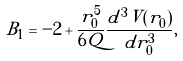Convert formula to latex. <formula><loc_0><loc_0><loc_500><loc_500>B _ { 1 } = - 2 + \frac { r _ { 0 } ^ { 5 } } { 6 Q } \frac { d ^ { 3 } V ( r _ { 0 } ) } { d r _ { 0 } ^ { 3 } } ,</formula> 